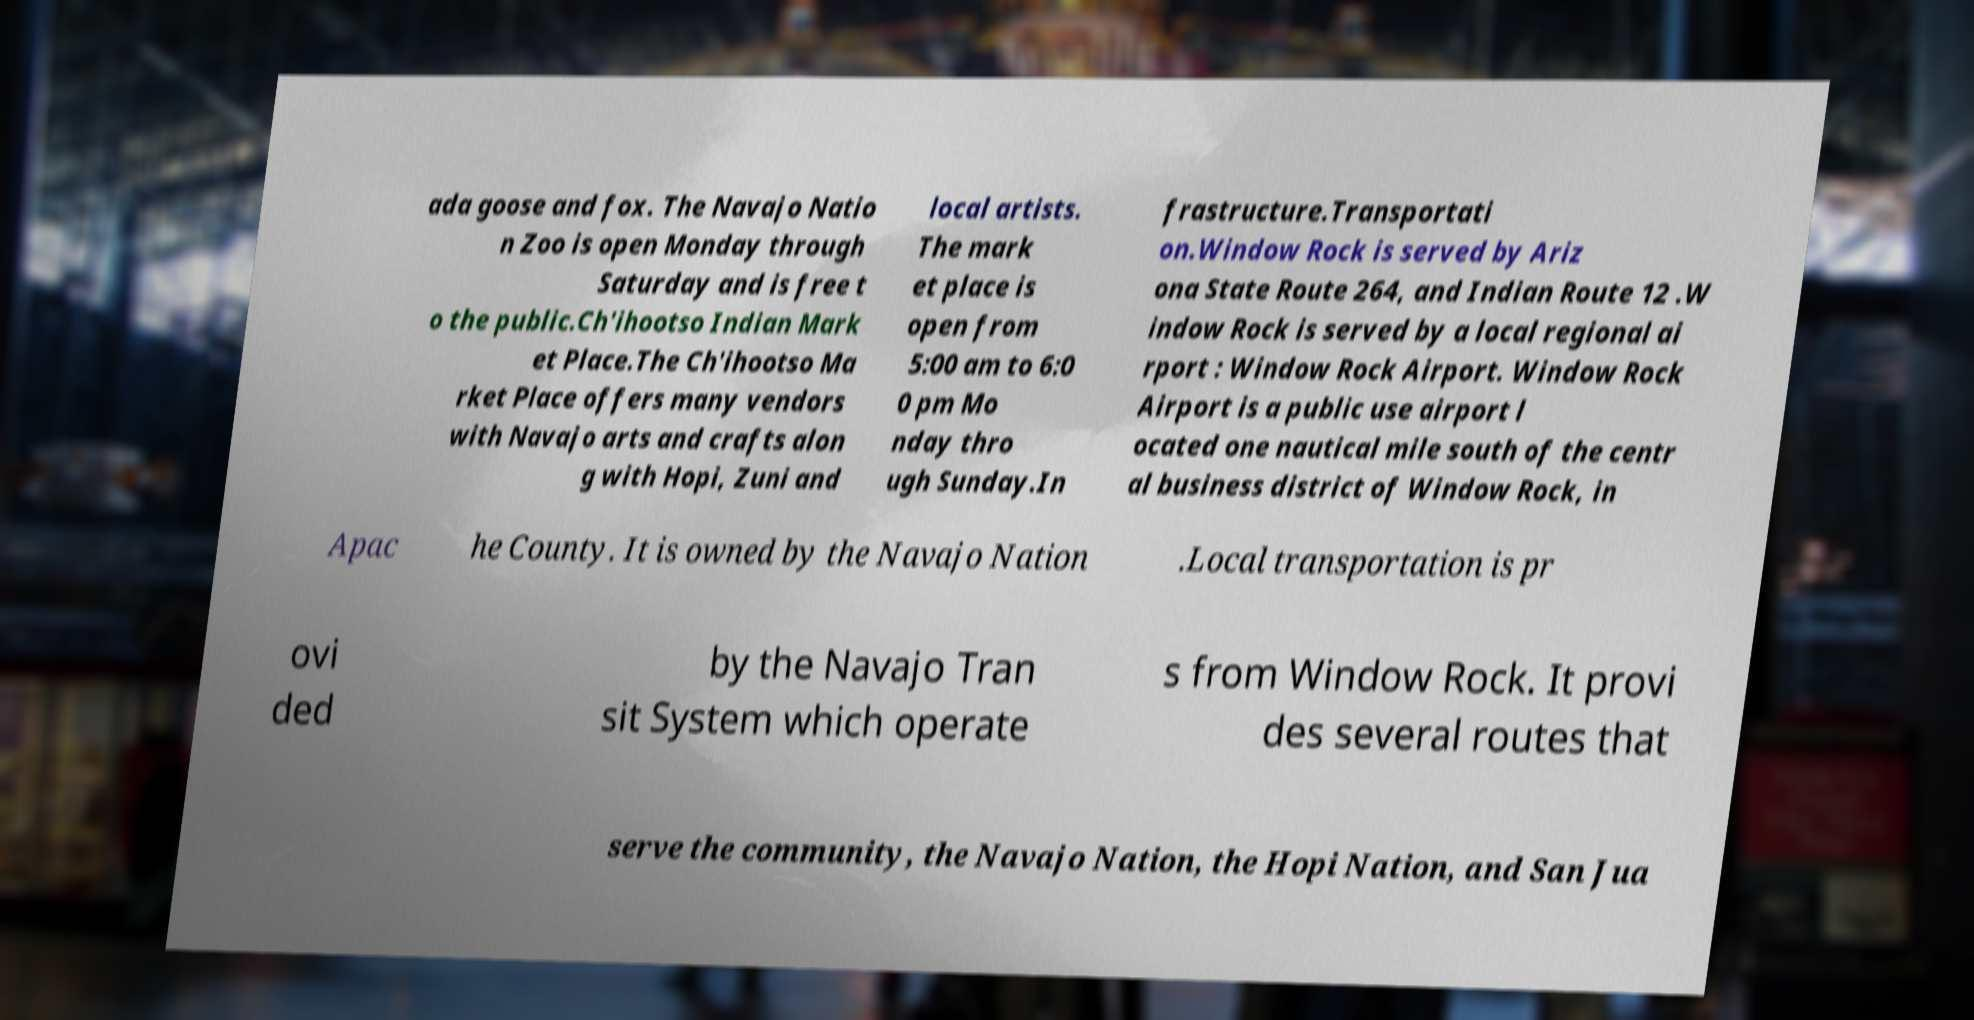Can you read and provide the text displayed in the image?This photo seems to have some interesting text. Can you extract and type it out for me? ada goose and fox. The Navajo Natio n Zoo is open Monday through Saturday and is free t o the public.Ch'ihootso Indian Mark et Place.The Ch'ihootso Ma rket Place offers many vendors with Navajo arts and crafts alon g with Hopi, Zuni and local artists. The mark et place is open from 5:00 am to 6:0 0 pm Mo nday thro ugh Sunday.In frastructure.Transportati on.Window Rock is served by Ariz ona State Route 264, and Indian Route 12 .W indow Rock is served by a local regional ai rport : Window Rock Airport. Window Rock Airport is a public use airport l ocated one nautical mile south of the centr al business district of Window Rock, in Apac he County. It is owned by the Navajo Nation .Local transportation is pr ovi ded by the Navajo Tran sit System which operate s from Window Rock. It provi des several routes that serve the community, the Navajo Nation, the Hopi Nation, and San Jua 